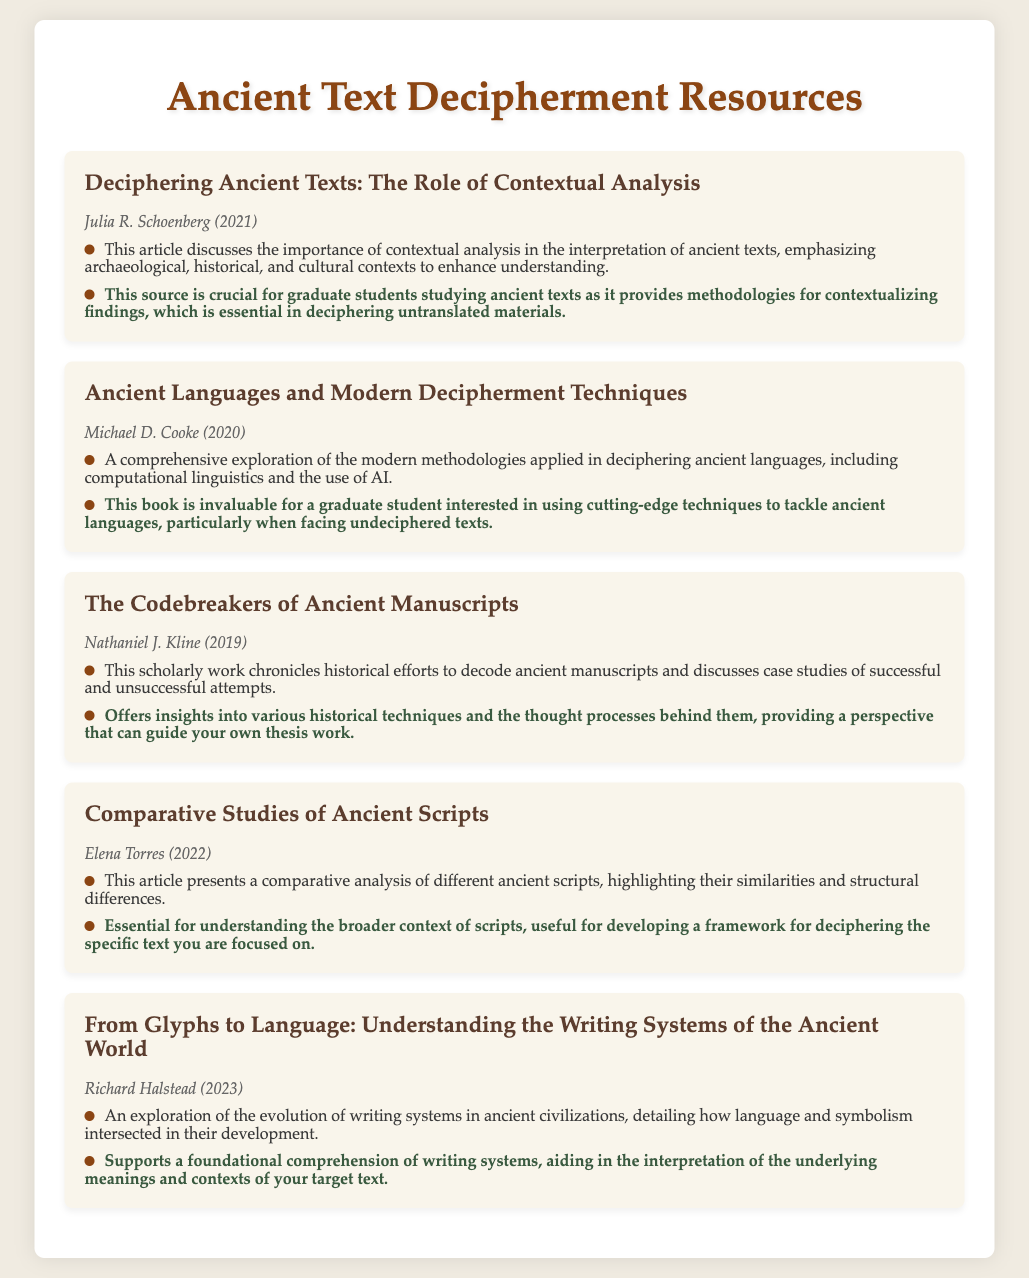What is the title of the first article listed? The title of the first article, as shown in the document, is "Deciphering Ancient Texts: The Role of Contextual Analysis."
Answer: Deciphering Ancient Texts: The Role of Contextual Analysis Who is the author of the second item? The author of the second item is mentioned right below the title of the article, which is "Michael D. Cooke."
Answer: Michael D. Cooke In which year was the fourth article published? The year the fourth article was published can be found alongside the author's name, which states "2022."
Answer: 2022 What is the main focus of Richard Halstead's work? The summary for Richard Halstead's work describes it as an exploration of the evolution of writing systems in ancient civilizations.
Answer: Evolution of writing systems Which article emphasizes contextual analysis? The first article specifically addresses the importance of contextual analysis in the interpretation of ancient texts.
Answer: Deciphering Ancient Texts: The Role of Contextual Analysis How many articles are listed in total? The total number of articles is equal to the number of "menu-item" entries in the document, which is five.
Answer: Five 